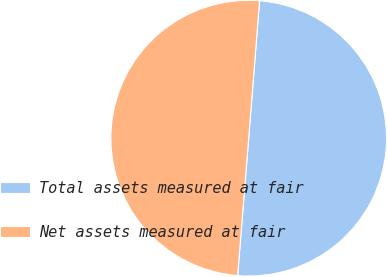<chart> <loc_0><loc_0><loc_500><loc_500><pie_chart><fcel>Total assets measured at fair<fcel>Net assets measured at fair<nl><fcel>50.02%<fcel>49.98%<nl></chart> 